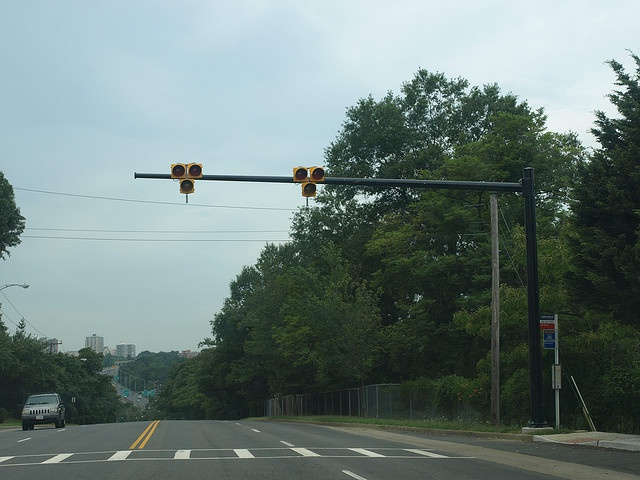Describe the objects in this image and their specific colors. I can see car in lightblue, black, gray, darkgray, and purple tones, traffic light in lightblue, black, olive, and gray tones, and traffic light in lightblue, black, olive, and maroon tones in this image. 